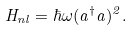Convert formula to latex. <formula><loc_0><loc_0><loc_500><loc_500>H _ { n l } = \hbar { \omega } ( a ^ { \dagger } a ) ^ { 2 } .</formula> 